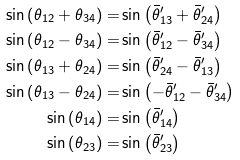Convert formula to latex. <formula><loc_0><loc_0><loc_500><loc_500>\sin \left ( \theta _ { 1 2 } + \theta _ { 3 4 } \right ) = & \sin \left ( \bar { \theta } _ { 1 3 } ^ { \prime } + \bar { \theta } _ { 2 4 } ^ { \prime } \right ) \\ \sin \left ( \theta _ { 1 2 } - \theta _ { 3 4 } \right ) = & \sin \left ( \bar { \theta } _ { 1 2 } ^ { \prime } - \bar { \theta } _ { 3 4 } ^ { \prime } \right ) \\ \sin \left ( \theta _ { 1 3 } + \theta _ { 2 4 } \right ) = & \sin \left ( \bar { \theta } _ { 2 4 } ^ { \prime } - \bar { \theta } _ { 1 3 } ^ { \prime } \right ) \\ \sin \left ( \theta _ { 1 3 } - \theta _ { 2 4 } \right ) = & \sin \left ( - \bar { \theta } _ { 1 2 } ^ { \prime } - \bar { \theta } _ { 3 4 } ^ { \prime } \right ) \\ \sin \left ( \theta _ { 1 4 } \right ) = & \sin \left ( \bar { \theta } _ { 1 4 } ^ { \prime } \right ) \\ \sin \left ( \theta _ { 2 3 } \right ) = & \sin \left ( \bar { \theta } _ { 2 3 } ^ { \prime } \right )</formula> 